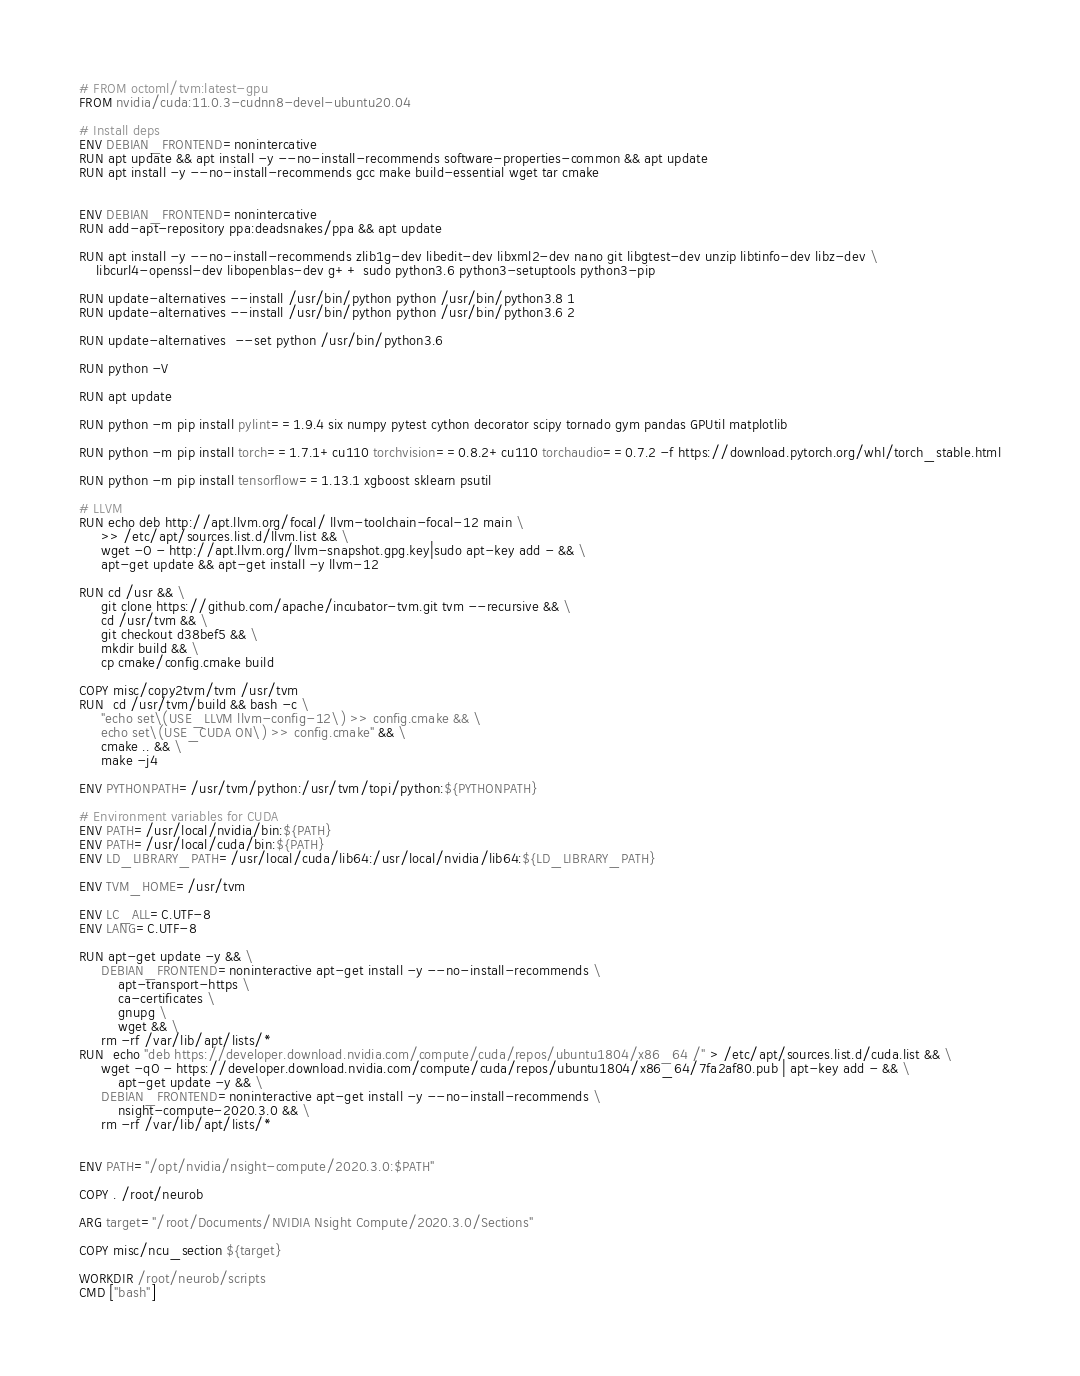<code> <loc_0><loc_0><loc_500><loc_500><_Dockerfile_># FROM octoml/tvm:latest-gpu
FROM nvidia/cuda:11.0.3-cudnn8-devel-ubuntu20.04

# Install deps
ENV DEBIAN_FRONTEND=nonintercative
RUN apt update && apt install -y --no-install-recommends software-properties-common && apt update
RUN apt install -y --no-install-recommends gcc make build-essential wget tar cmake


ENV DEBIAN_FRONTEND=nonintercative
RUN add-apt-repository ppa:deadsnakes/ppa && apt update 

RUN apt install -y --no-install-recommends zlib1g-dev libedit-dev libxml2-dev nano git libgtest-dev unzip libtinfo-dev libz-dev \
    libcurl4-openssl-dev libopenblas-dev g++ sudo python3.6 python3-setuptools python3-pip

RUN update-alternatives --install /usr/bin/python python /usr/bin/python3.8 1
RUN update-alternatives --install /usr/bin/python python /usr/bin/python3.6 2

RUN update-alternatives  --set python /usr/bin/python3.6

RUN python -V

RUN apt update

RUN python -m pip install pylint==1.9.4 six numpy pytest cython decorator scipy tornado gym pandas GPUtil matplotlib

RUN python -m pip install torch==1.7.1+cu110 torchvision==0.8.2+cu110 torchaudio==0.7.2 -f https://download.pytorch.org/whl/torch_stable.html

RUN python -m pip install tensorflow==1.13.1 xgboost sklearn psutil

# LLVM
RUN echo deb http://apt.llvm.org/focal/ llvm-toolchain-focal-12 main \
     >> /etc/apt/sources.list.d/llvm.list && \
     wget -O - http://apt.llvm.org/llvm-snapshot.gpg.key|sudo apt-key add - && \
     apt-get update && apt-get install -y llvm-12

RUN cd /usr && \
     git clone https://github.com/apache/incubator-tvm.git tvm --recursive && \
     cd /usr/tvm && \
     git checkout d38bef5 && \
     mkdir build && \
     cp cmake/config.cmake build

COPY misc/copy2tvm/tvm /usr/tvm
RUN  cd /usr/tvm/build && bash -c \
     "echo set\(USE_LLVM llvm-config-12\) >> config.cmake && \
     echo set\(USE_CUDA ON\) >> config.cmake" && \
     cmake .. && \
     make -j4 

ENV PYTHONPATH=/usr/tvm/python:/usr/tvm/topi/python:${PYTHONPATH}

# Environment variables for CUDA
ENV PATH=/usr/local/nvidia/bin:${PATH}
ENV PATH=/usr/local/cuda/bin:${PATH}
ENV LD_LIBRARY_PATH=/usr/local/cuda/lib64:/usr/local/nvidia/lib64:${LD_LIBRARY_PATH}

ENV TVM_HOME=/usr/tvm

ENV LC_ALL=C.UTF-8
ENV LANG=C.UTF-8

RUN apt-get update -y && \
     DEBIAN_FRONTEND=noninteractive apt-get install -y --no-install-recommends \
         apt-transport-https \
         ca-certificates \
         gnupg \
         wget && \
     rm -rf /var/lib/apt/lists/*
RUN  echo "deb https://developer.download.nvidia.com/compute/cuda/repos/ubuntu1804/x86_64 /" > /etc/apt/sources.list.d/cuda.list && \
     wget -qO - https://developer.download.nvidia.com/compute/cuda/repos/ubuntu1804/x86_64/7fa2af80.pub | apt-key add - && \
         apt-get update -y && \
     DEBIAN_FRONTEND=noninteractive apt-get install -y --no-install-recommends \
         nsight-compute-2020.3.0 && \
     rm -rf /var/lib/apt/lists/*


ENV PATH="/opt/nvidia/nsight-compute/2020.3.0:$PATH"

COPY . /root/neurob

ARG target="/root/Documents/NVIDIA Nsight Compute/2020.3.0/Sections"

COPY misc/ncu_section ${target}

WORKDIR /root/neurob/scripts
CMD ["bash"]</code> 